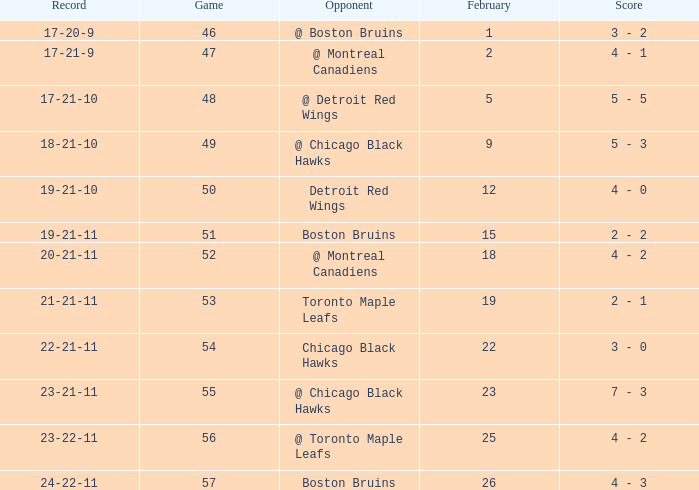What is the score of the game before 56 held after February 18 against the Chicago Black Hawks. 3 - 0. 